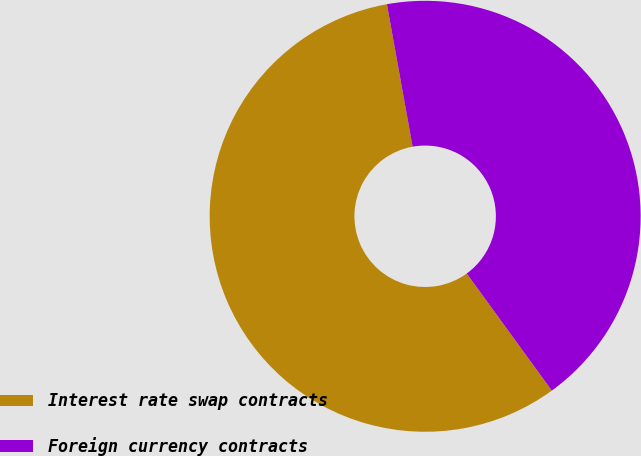Convert chart to OTSL. <chart><loc_0><loc_0><loc_500><loc_500><pie_chart><fcel>Interest rate swap contracts<fcel>Foreign currency contracts<nl><fcel>57.16%<fcel>42.84%<nl></chart> 